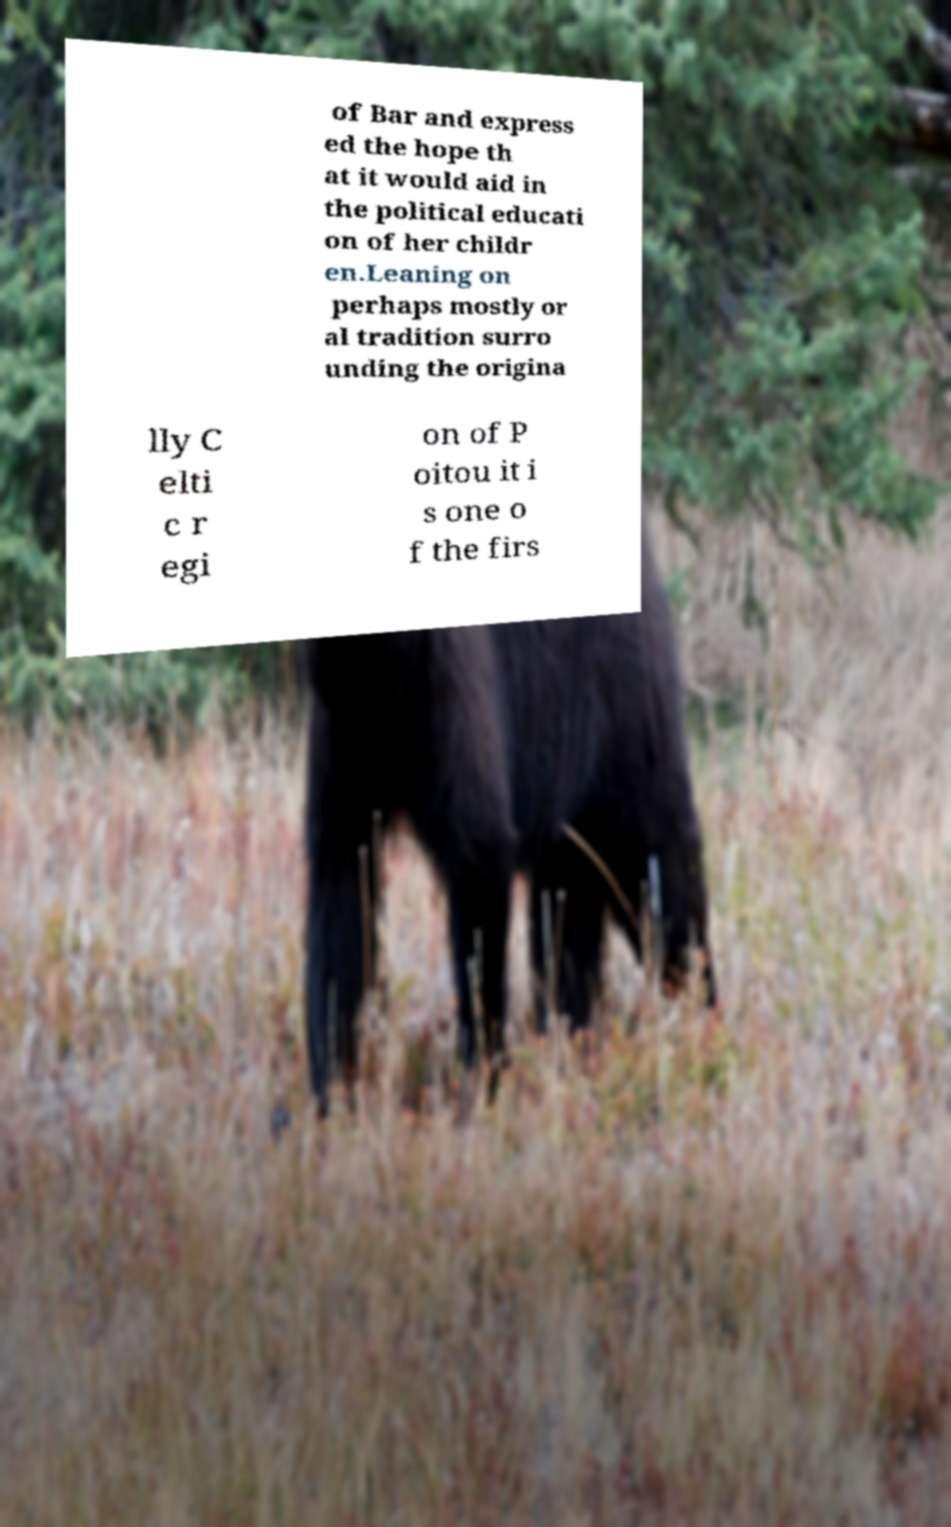Could you assist in decoding the text presented in this image and type it out clearly? of Bar and express ed the hope th at it would aid in the political educati on of her childr en.Leaning on perhaps mostly or al tradition surro unding the origina lly C elti c r egi on of P oitou it i s one o f the firs 